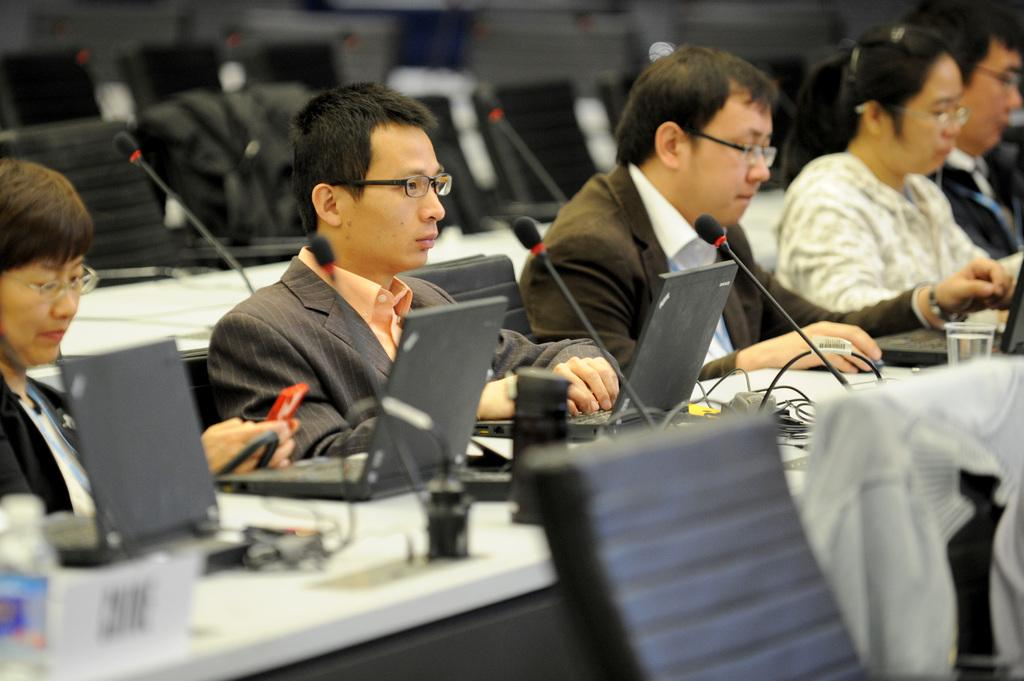What are the people in the image doing? The people in the image are sitting. What furniture is present in the image? There are chairs and tables in the image. What objects can be seen on the tables? There are devices on the tables. What else is visible in the image besides the people and furniture? There are clothes visible in the image. What historical event is being commemorated by the people in the image? There is no indication of a historical event being commemorated in the image. 